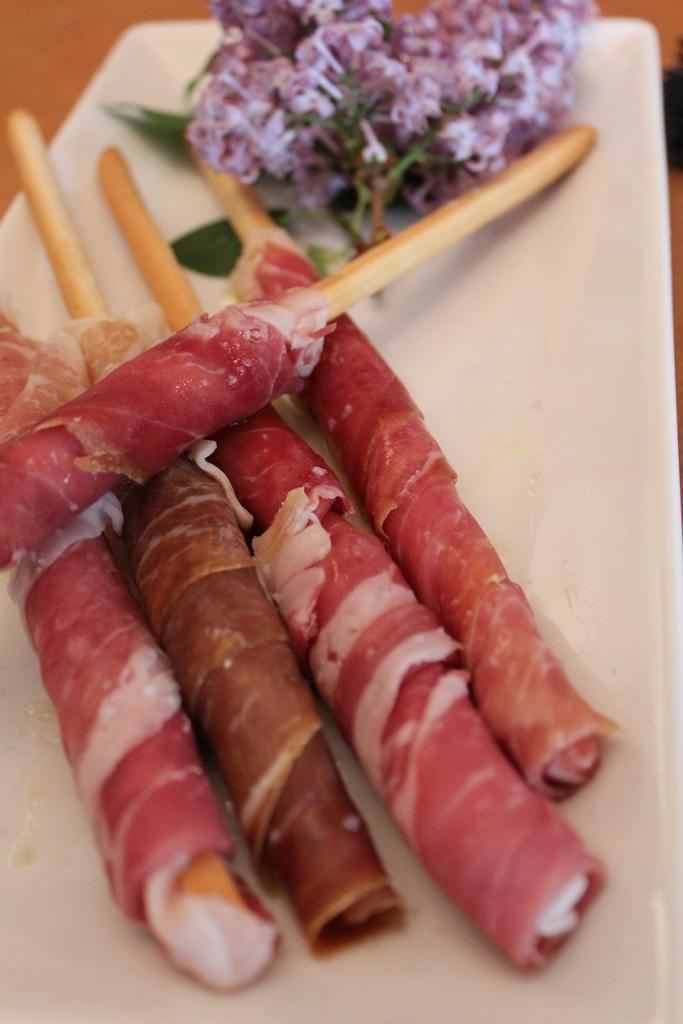What is on the plate in the image? There is a food item with garnish on the plate. What type of food is the main component of the dish? The food item is made of meat. What can be seen in the background of the image? There is a table in the background of the image. What type of card is being used as a decoration on the meat dish? There is no card present in the image; it features a food item with garnish on a plate. What kind of quartz is visible on the table in the image? There is no quartz present in the image; it only shows a food item with garnish on a plate and a table in the background. 